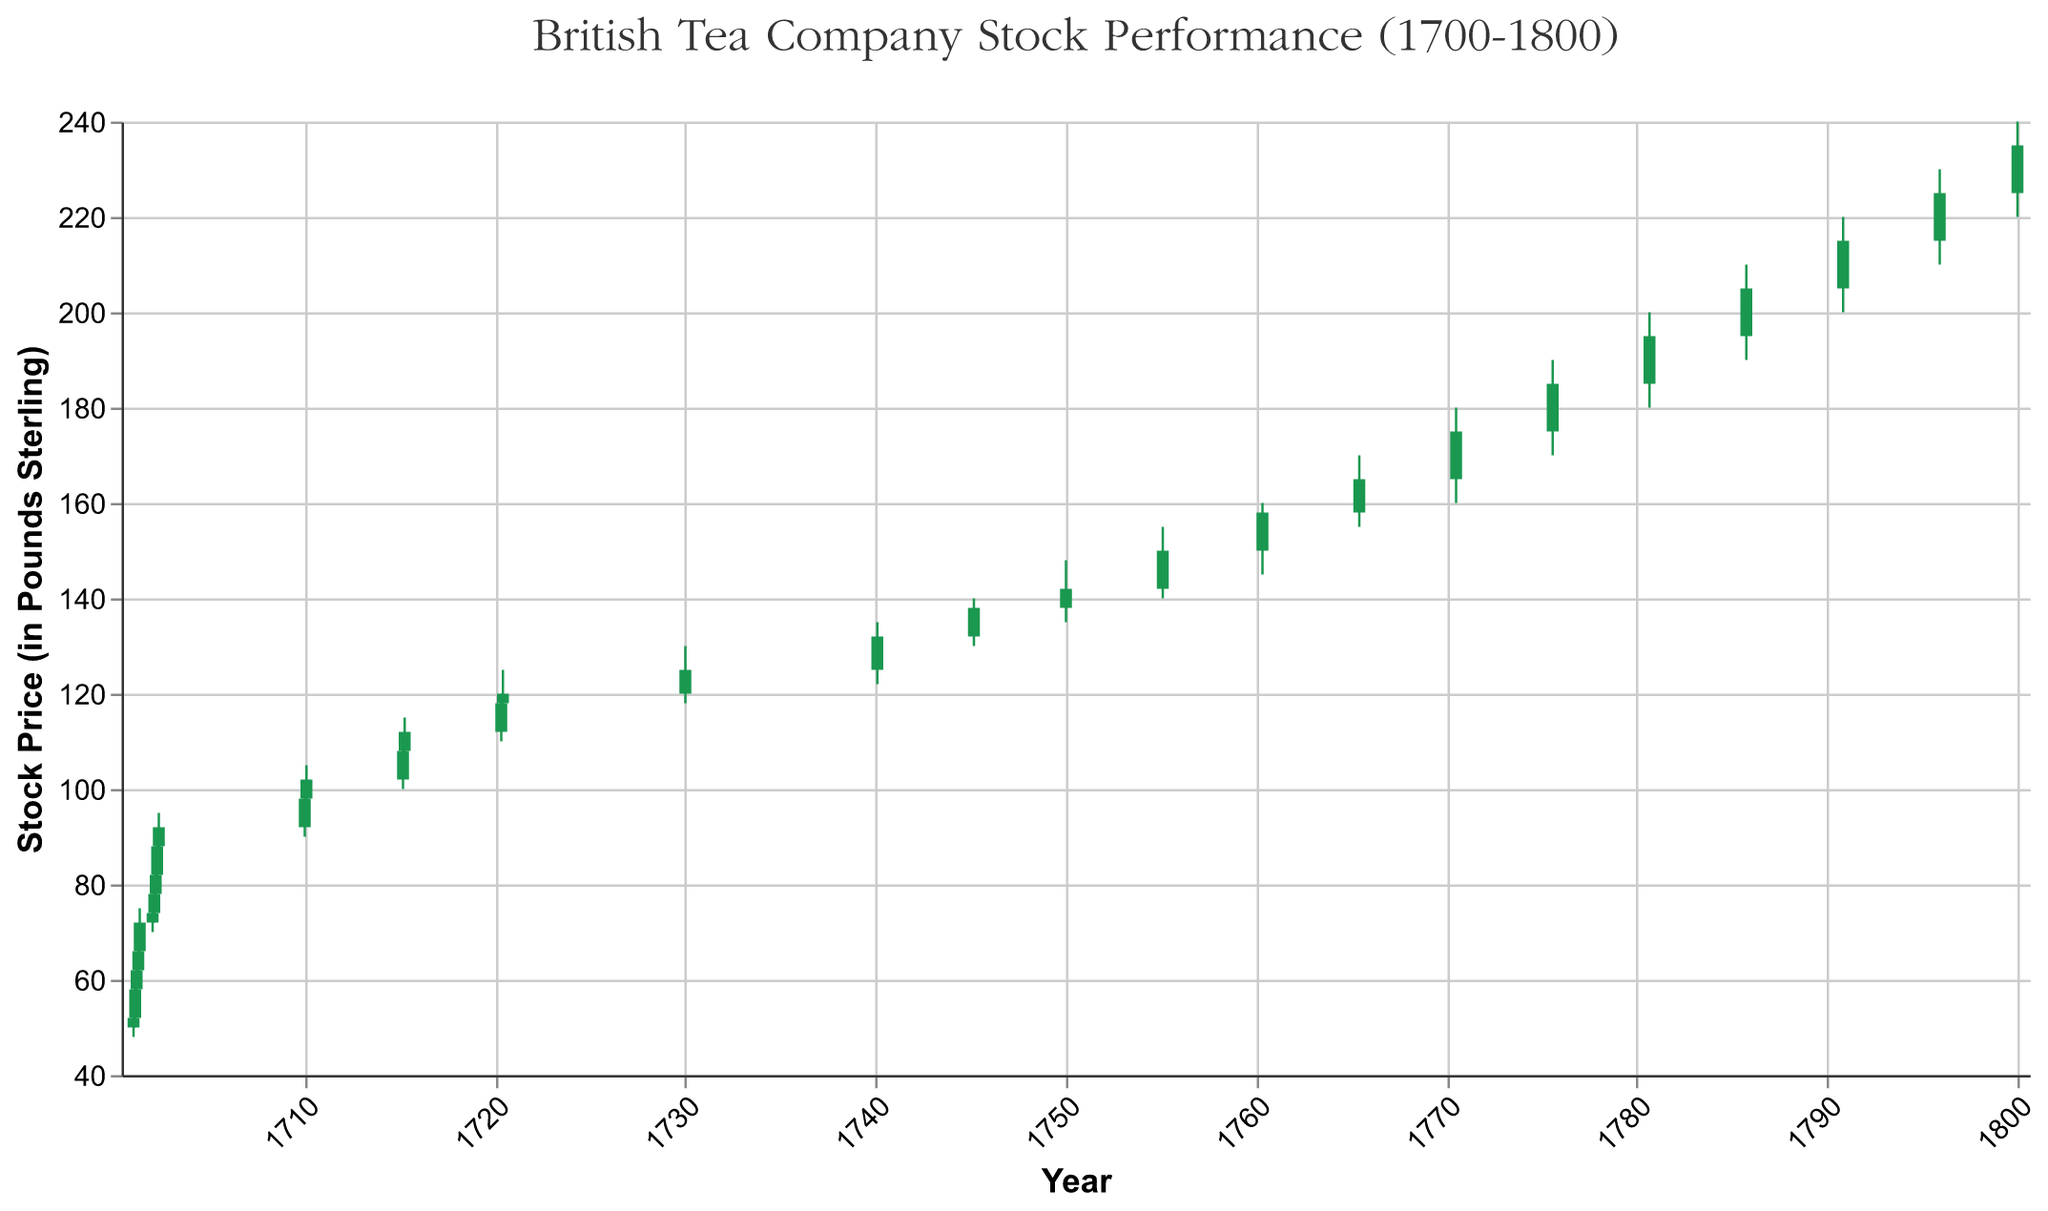What is the highest stock price in the dataset? The highest stock price is the maximum value in the "High" column. By reviewing the figure, the highest point on the y-axis represents this maximum value.
Answer: 240.00 What is the title of the figure? The title is found at the top of the figure, summarizing the data presented.
Answer: British Tea Company Stock Performance (1700-1800) How many data points are shown between 1700 to 1720? Count the number of candlestick patterns within the visual range from 1700 to 1720 on the x-axis.
Answer: 14 Which year's candlestick has the largest range between high and low prices? Compare the range (High - Low) for each candlestick. The largest range is recognized by the lengthiest vertical extent of the candlestick.
Answer: 1795 (Range: 20) What was the closing price at the end of 1710? Identify the candlestick for 1710-12-31 by examining the x-axis. The closing price is found at the top of the filled bar if green or at the bottom if red.
Answer: 102 Which period experienced the fastest rise in stock prices? Determine the period with the steepest upward slope by comparing the change in closing prices between consecutive candlesticks over different periods. Calculate the difference for each period, and the highest positive difference indicates the fastest rise.
Answer: 1701-05 to 1702-01 When was the largest drop in stock price observed? Compare the differences between the high and low prices across all data points to find the largest negative change.
Answer: 1745-03 to 1750-01 During which year did the stock price surpass 100 for the first time? Analyze the timeline on the x-axis and identify the first occurrence where the closing price exceeds 100, noting the year on the x-axis.
Answer: 1710 What is the longest period without any data points shown in the figure? Assess the gaps between the dates on the x-axis, identifying the longest interval.
Answer: 1720 to 1730 How does the stock price trajectory from 1770 to 1780 compare to that from 1780 to 1790? Compare the slope and differences in the closing prices for both periods by noting the relative changes in the y-axis positions. Observing the visual difference and steepness of slopes helps in comparison.
Answer: 1770-1780 (10) shows less growth compared to 1780-1790 (20) 